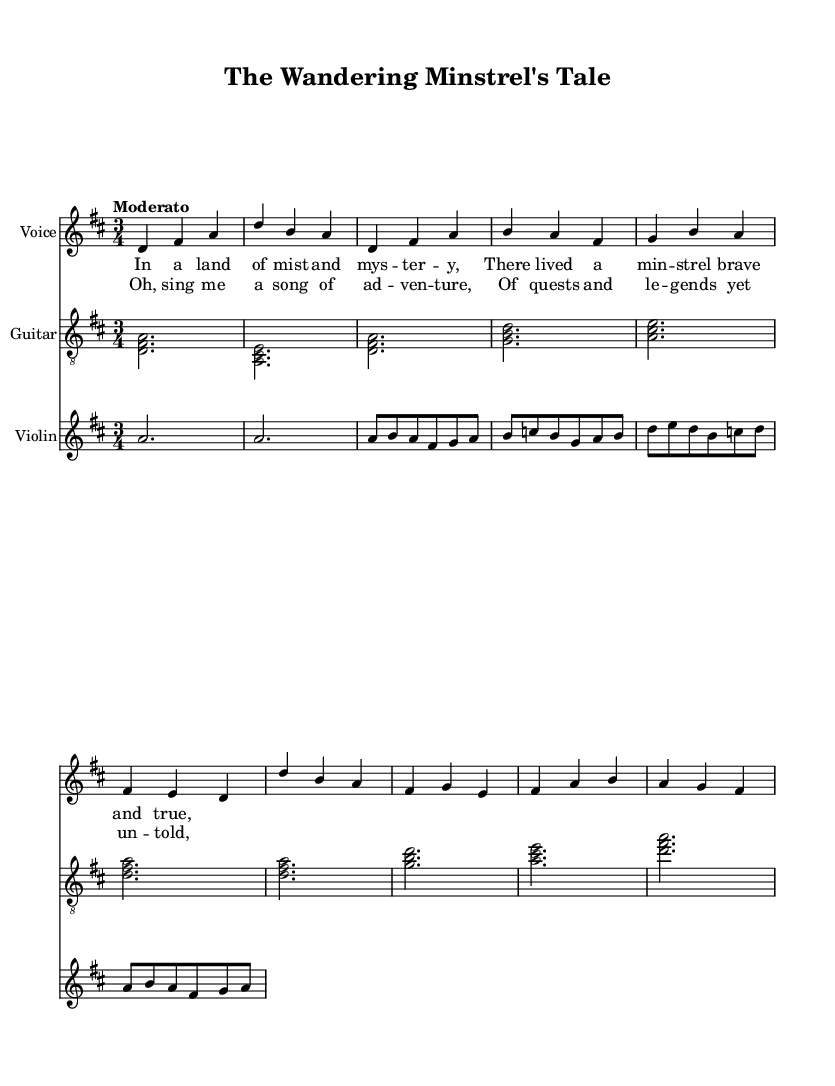What is the key signature of this music? The key signature is indicated at the beginning of the music sheet. It shows two sharps, which correspond to F# and C#. This means the piece is in D major.
Answer: D major What is the time signature of this music? The time signature is shown at the beginning of the music sheet, with the top number indicating the number of beats per measure (3) and the bottom number indicating the note value that gets one beat (4). Thus, it reads as three beats in a measure, quarter note gets one beat.
Answer: 3/4 What is the tempo marking for this piece? The tempo marking is displayed at the beginning of the music. It states "Moderato," indicating a moderate pace for the performance.
Answer: Moderato What instruments are featured in this composition? The instruments are listed in the music sheet under each staff. There are three staves: one for voice, one for guitar, and one for violin. The instruments are clearly mentioned as "Voice," "Guitar," and "Violin."
Answer: Voice, Guitar, Violin How many verses does the piece contain? The piece includes the structure of lyrics provided. The lyrics section only shows one complete verse and a chorus following it, which indicates that there is one verse presented in the sheet music.
Answer: One What phrase is repeated in the chorus? To find the repeated phrases, we look at the chorus lyrics provided; the phrase "Oh, sing me a song" is seen at the beginning and stands out as a memorable line in the piece.
Answer: Oh, sing me a song Identify the dynamic marking for the violin part during the intro. The dynamic markings for dynamic levels in the music indicate how loud or soft the notes should be played. In this case, the violin section has no markings in the intro, suggesting it's played at a moderate volume or according to the interpretative discretion of the performer.
Answer: None 